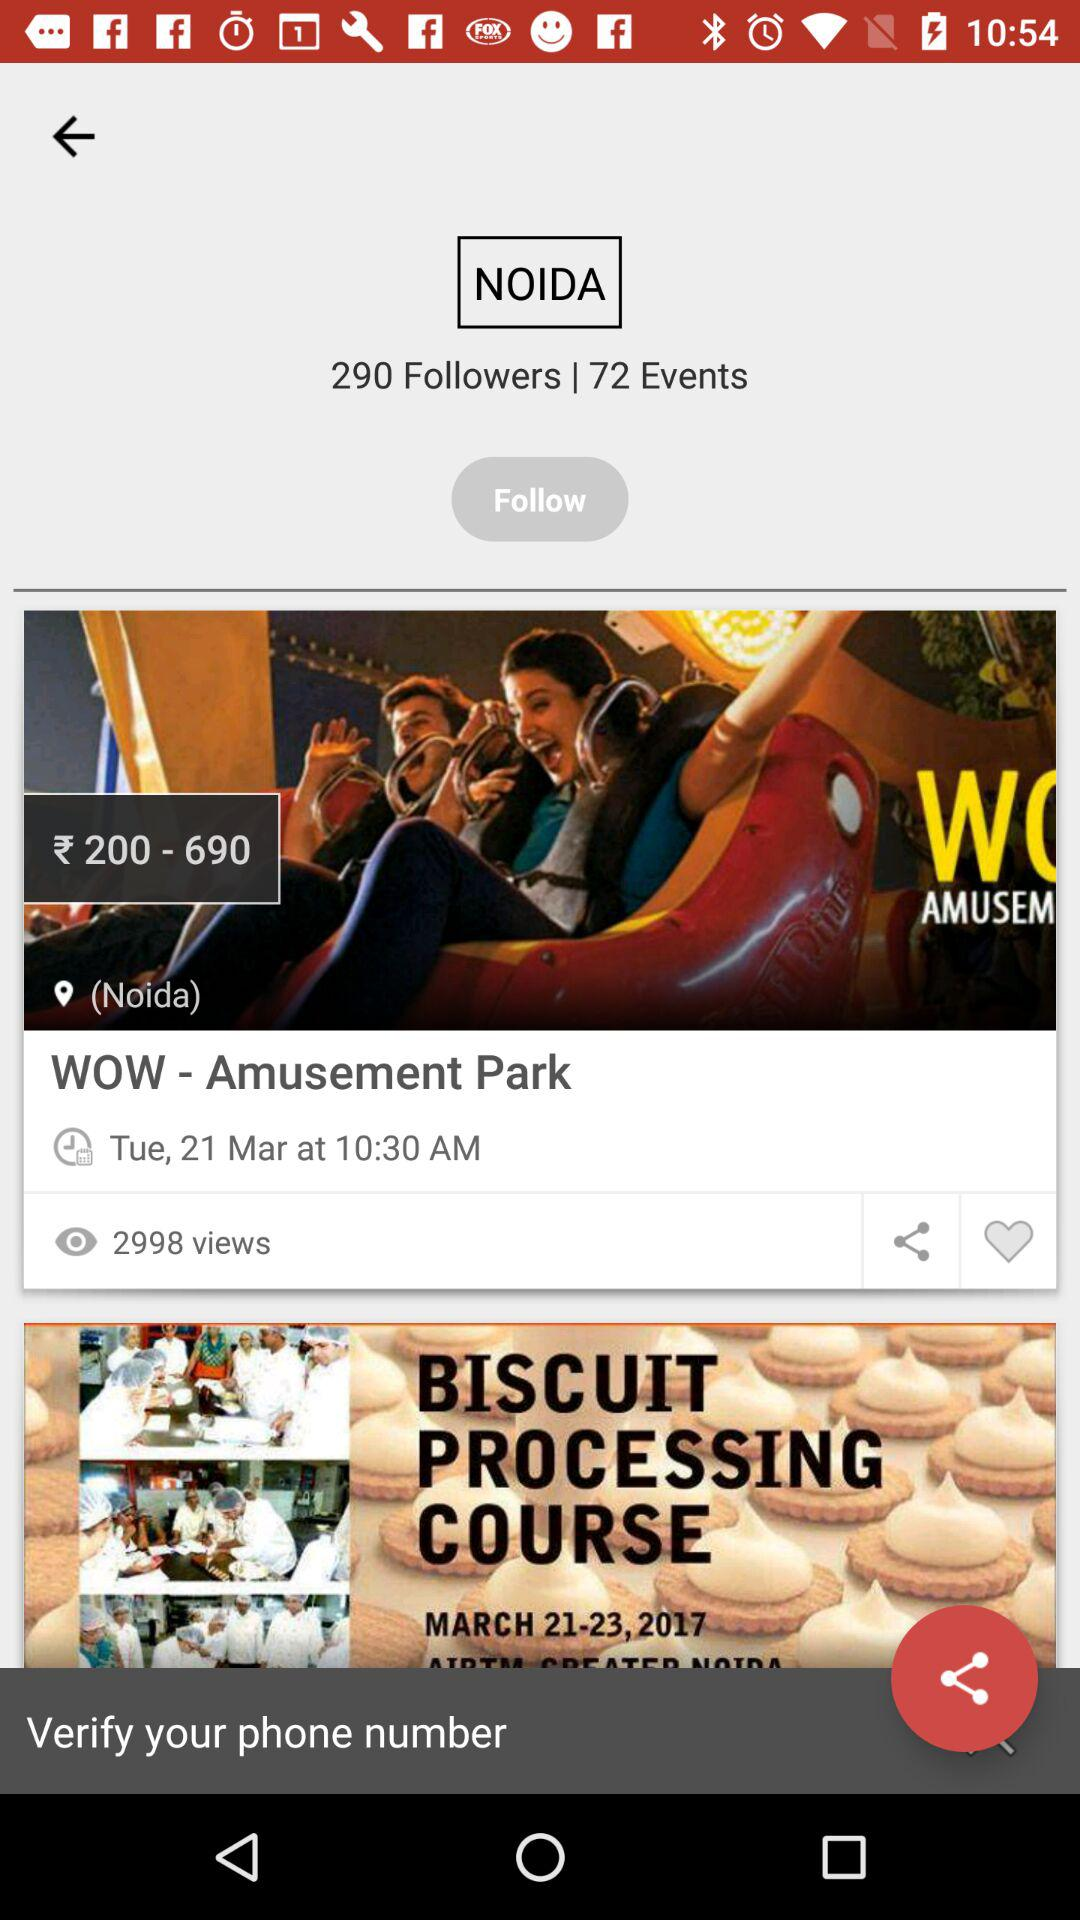What is the ticket price for "WOW - Amusement Park"? The ticket price for "WOW - Amusement Park" ranges from ₹200 to ₹690. 